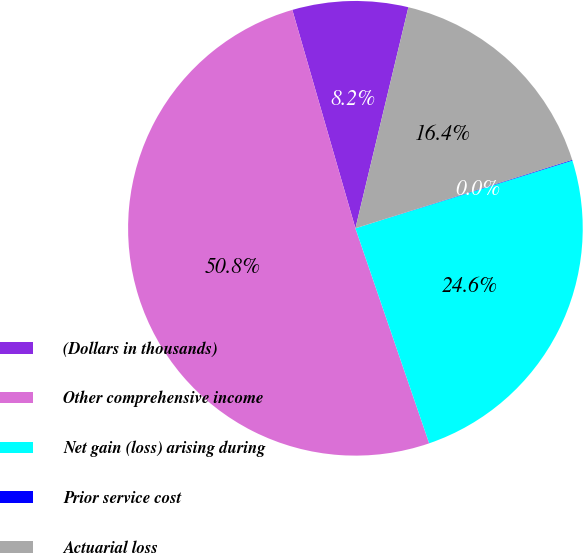Convert chart to OTSL. <chart><loc_0><loc_0><loc_500><loc_500><pie_chart><fcel>(Dollars in thousands)<fcel>Other comprehensive income<fcel>Net gain (loss) arising during<fcel>Prior service cost<fcel>Actuarial loss<nl><fcel>8.22%<fcel>50.79%<fcel>24.56%<fcel>0.05%<fcel>16.39%<nl></chart> 